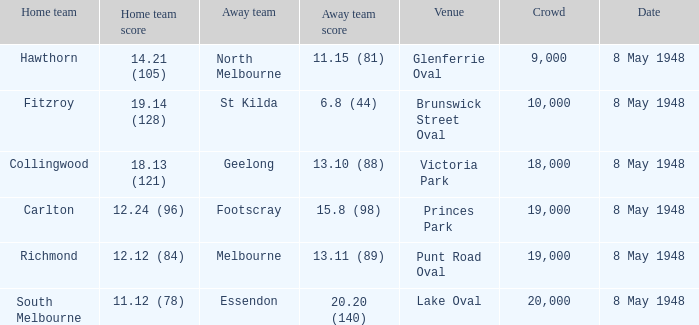Which team, playing at home, scored 11.12 (78)? South Melbourne. 